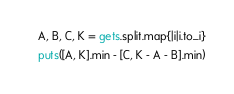<code> <loc_0><loc_0><loc_500><loc_500><_Ruby_>A, B, C, K = gets.split.map{|i|i.to_i}
puts([A, K].min - [C, K - A - B].min)
</code> 